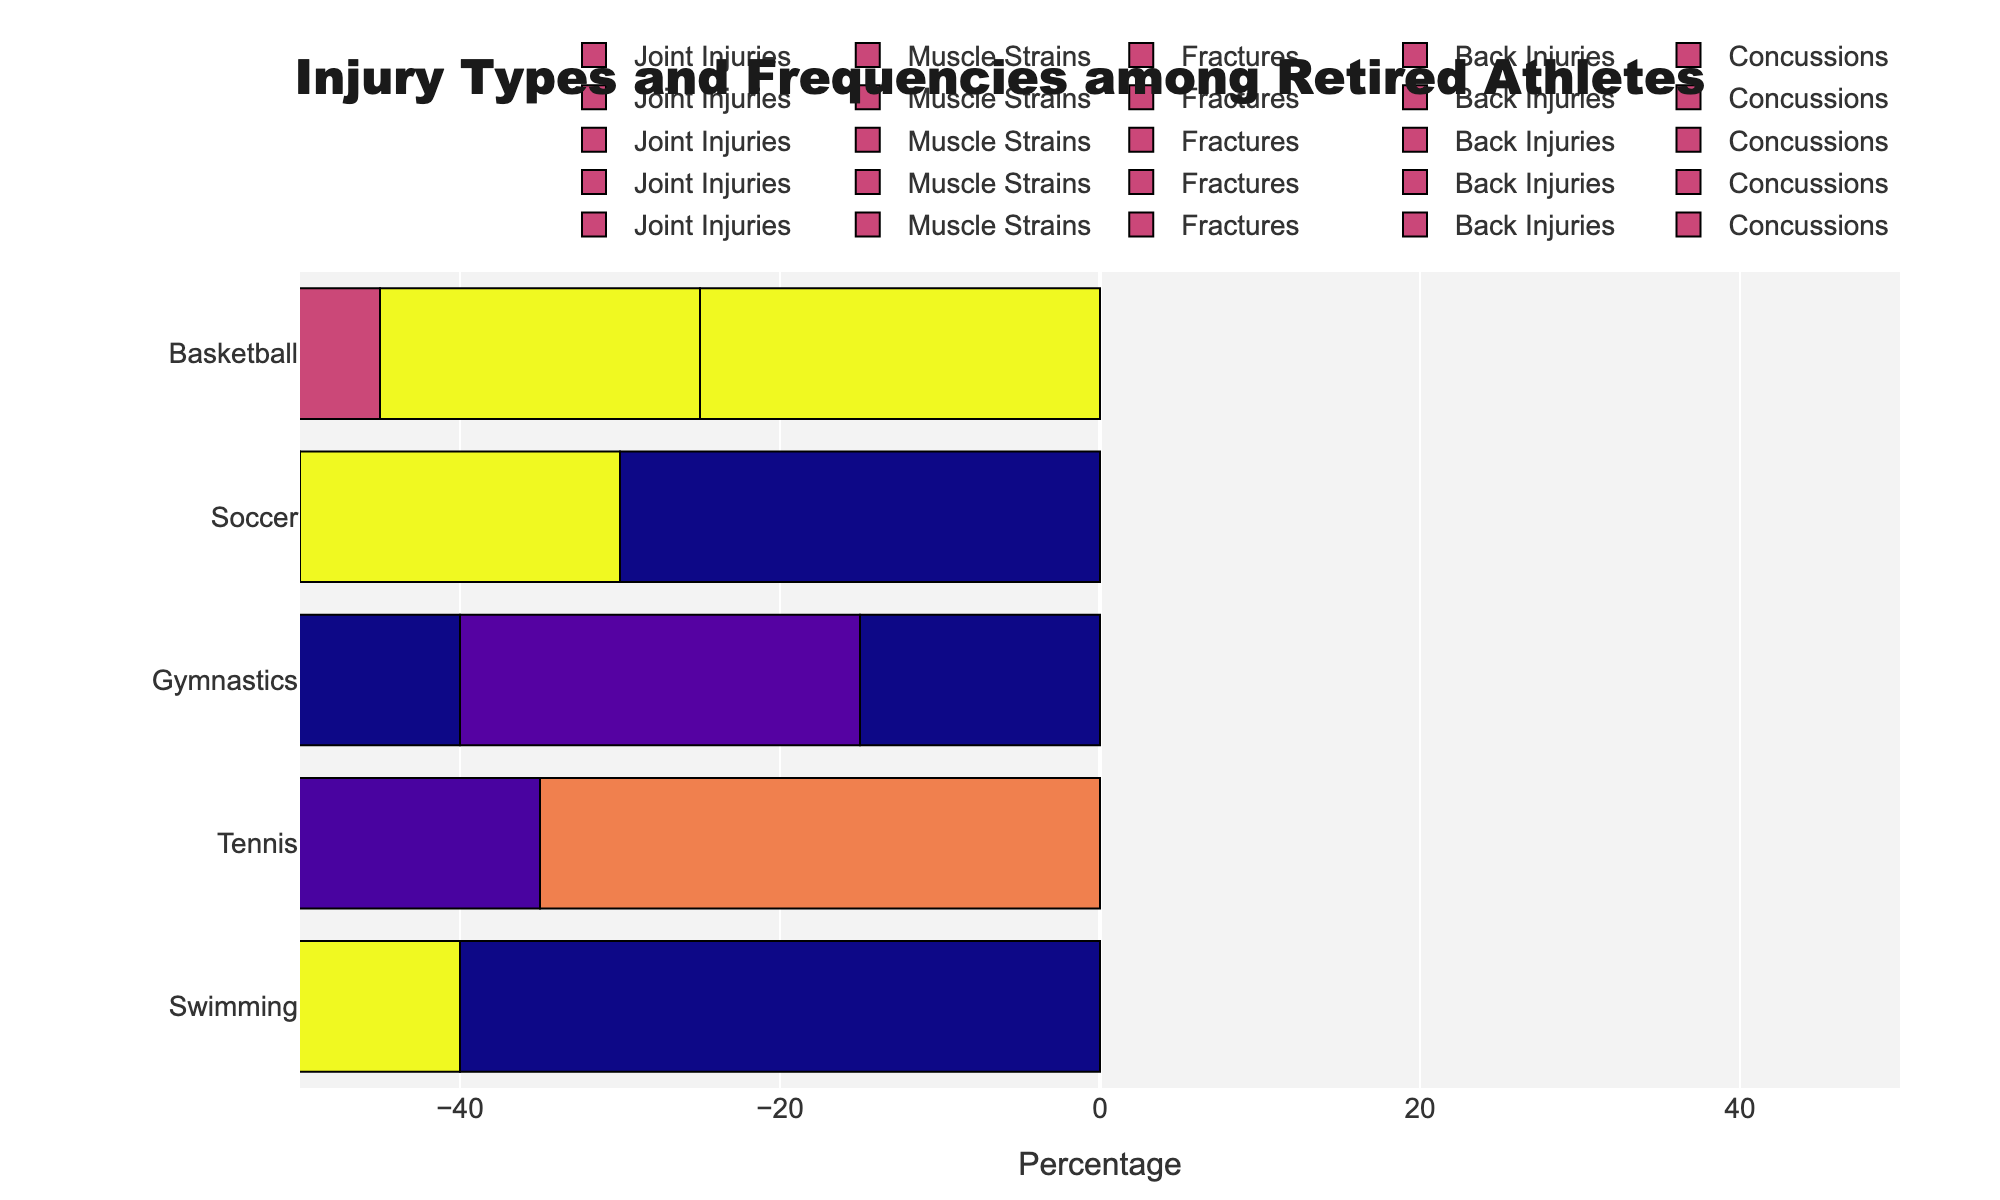What proportion of retired gymnasts reported fractures compared to retired basketball players? To determine this, find the percentage of fractures reported by retired gymnasts and retired basketball players. For gymnasts, it's 25%. For basketball players, it's 20%.
Answer: Gymnasts: 25%, Basketball players: 20% Which sport has the highest percentage of muscle strains among retired athletes? Compare the percentage of muscle strains for each sport: Gymnastics (25%), Soccer (30%), Swimming (40%), Basketball (30%), Tennis (35%). The highest is 40% for Swimming.
Answer: Swimming Which injury type is least common among retired soccer players? Review the percentages for all injury types reported by retired soccer players: Joint Injuries (20%), Muscle Strains (30%), Fractures (15%), Back Injuries (20%), Concussions (15%). The lowest value is Concussions at 15%.
Answer: Concussions What is the difference in the percentage of back injuries between retired gymnasts and retired swimmers? Retired gymnasts report 10% back injuries, while retired swimmers report 15%. The difference is 15% - 10% = 5%.
Answer: 5% How do the reports of joint injuries among retired tennis players compare to retired gymnasts? Retired tennis players report 25% joint injuries, and retired gymnasts report 35%.
Answer: Tennis: 25%, Gymnasts: 35% What is the combined percentage of muscle strains and back injuries reported by retired basketball players? Retired basketball players report 30% for muscle strains and 25% for back injuries. The combined percentage is 30% + 25% = 55%.
Answer: 55% Which sport has the lowest percentage of reported concussions among retired athletes? Compare the percentage of concussions for each sport: Gymnastics (5%), Soccer (15%), Swimming (5%), Basketball (0%), Tennis (5%). The lowest is Basketball with 0%.
Answer: Basketball What is the average percentage of fractures reported by all retired athletes across the five sports? Sum the percentage of fractures for all sports (Gymnastics: 25%, Soccer: 15%, Swimming: 5%, Basketball: 20%, Tennis: 10%) and divide by the number of sports (5). The calculation is (25% + 15% + 5% + 20% + 10%) / 5 = 15%.
Answer: 15% Compare the percentage of back injuries between retired soccer players and retired swimmers. Retired soccer players report 20% back injuries, while retired swimmers report 15%.
Answer: Soccer: 20%, Swimmers: 15% 